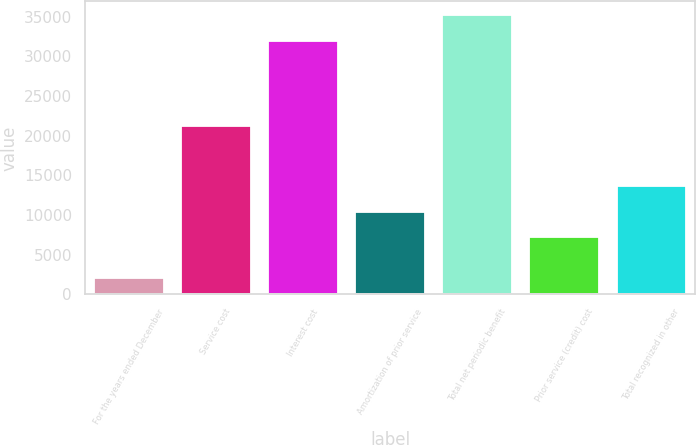Convert chart. <chart><loc_0><loc_0><loc_500><loc_500><bar_chart><fcel>For the years ended December<fcel>Service cost<fcel>Interest cost<fcel>Amortization of prior service<fcel>Total net periodic benefit<fcel>Prior service (credit) cost<fcel>Total recognized in other<nl><fcel>2018<fcel>21223<fcel>31943<fcel>10410.1<fcel>35155.1<fcel>7198<fcel>13622.2<nl></chart> 